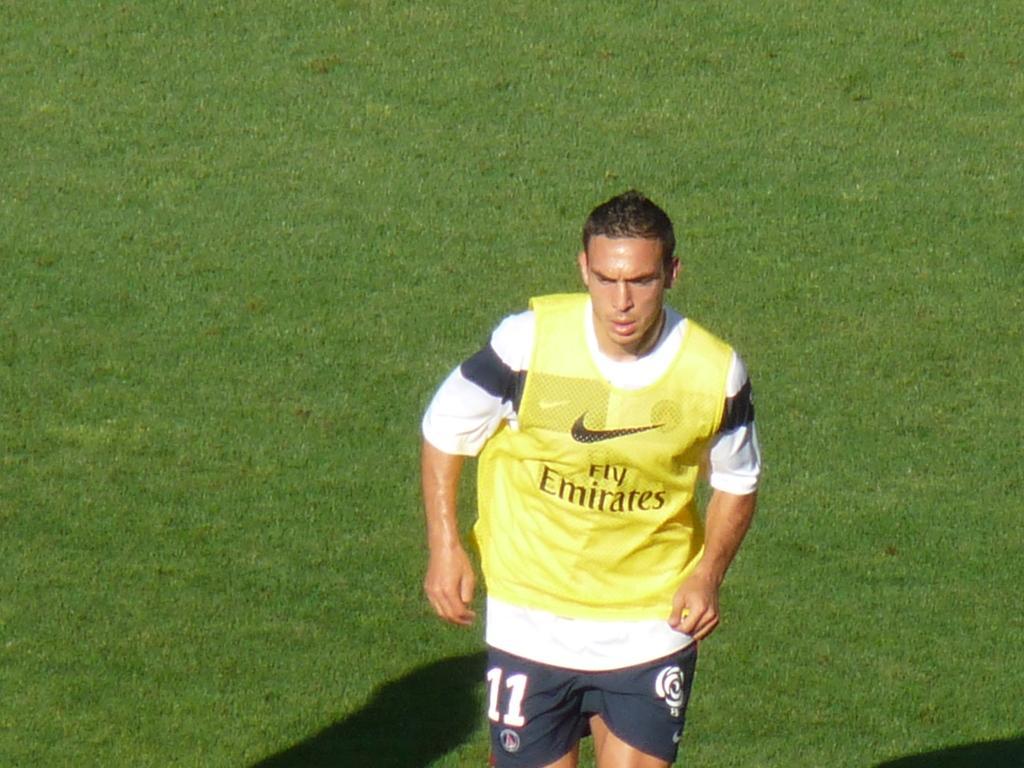Could you give a brief overview of what you see in this image? In the image I can see a man is standing on the ground. In the background I can see the grass and shadows. 